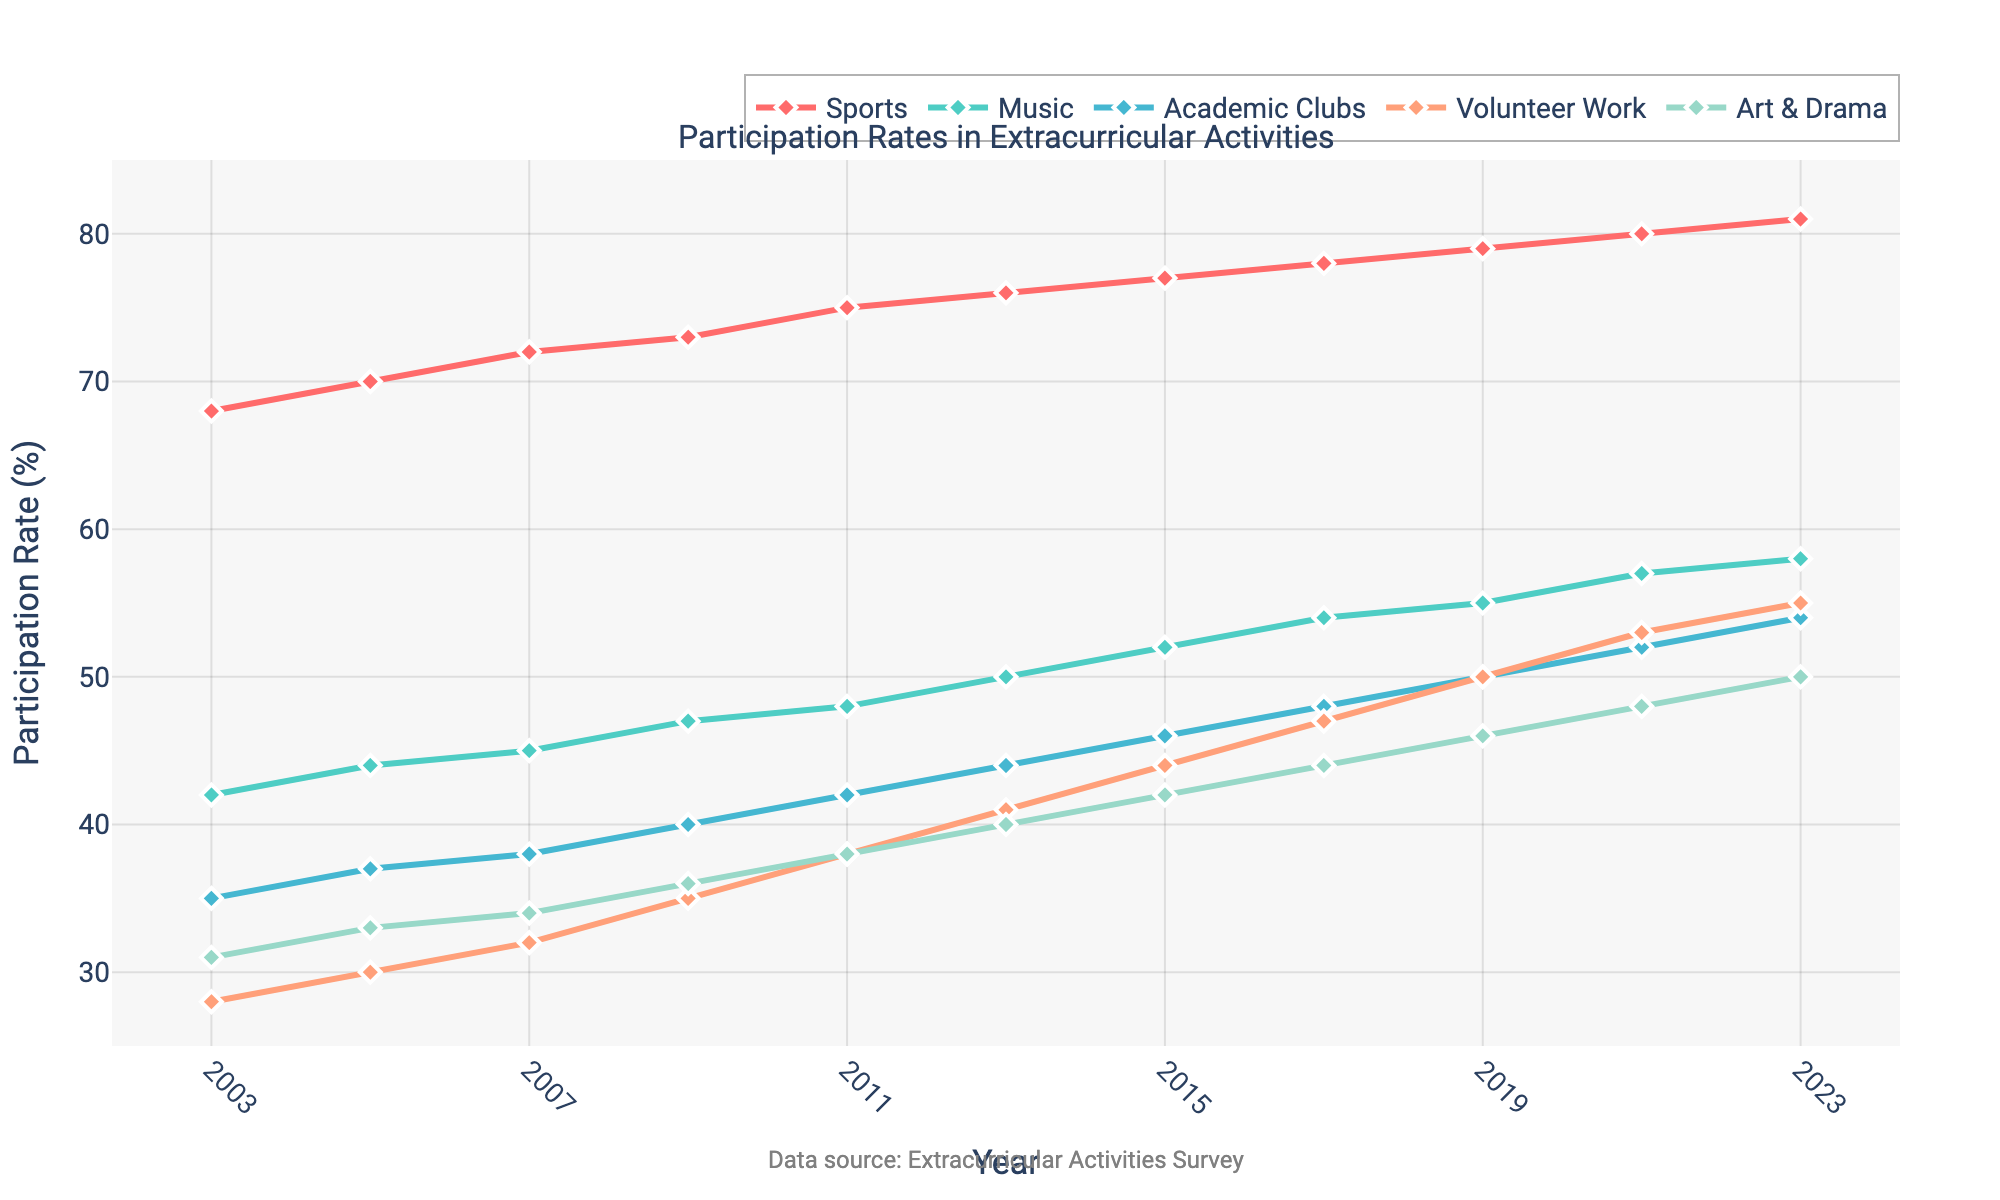What year had the highest participation in sports? To determine the year with the highest sports participation, we examine the line representing the sports on the chart and find the peak value. The highest sports participation rate is 81%, which occurs in the year 2023.
Answer: 2023 Which activity showed the greatest rate increase from 2003 to 2023? We need to calculate the increase in each activity's participation rate between 2003 and 2023 and then compare them. Sports increased by 13% (81% - 68%), Music by 16% (58% - 42%), Academic Clubs by 19% (54% - 35%), Volunteer Work by 27% (55% - 28%), and Art & Drama by 19% (50% - 31%). The highest increase is seen in Volunteer Work, which increased by 27%.
Answer: Volunteer Work How has participation in Music changed between 2011 and 2021? We compare the participation rates in Music for the years 2011 and 2021. In 2011, the participation rate was 48%, and in 2021, it was 57%. Therefore, there was an increase of 9% in Music participation from 2011 to 2021.
Answer: Increased by 9% In 2017, which activity had the lowest participation rate? By looking at the participation rates in 2017 for all activities, we identify the lowest rate. The rates are: Sports 78%, Music 54%, Academic Clubs 48%, Volunteer Work 47%, and Art & Drama 44%. The lowest rate is for Art & Drama at 44%.
Answer: Art & Drama What was the average participation rate for Academic Clubs from 2003 to 2023? To find the average, sum the participation rates of Academic Clubs for all given years and divide by the number of years. The rates are: 35, 37, 38, 40, 42, 44, 46, 48, 50, 52, 54. The total sum is 486, and there are 11 years, so the average is 486/11 ≈ 44.18%.
Answer: 44.18% Which year did Volunteer Work surpass 50% participation rate? We need to find the first year where the volunteer work participation rate exceeds 50%. Looking at the graph, this happens in 2019 when the participation rate reaches 50% and surpasses it in 2021 and 2023. The first occurrence is in 2019.
Answer: 2019 By how many percentage points did Art & Drama participation increase between 2003 and 2023? Subtract the participation rate of Art & Drama in 2003 from its rate in 2023. The rates are 31% in 2003 and 50% in 2023. The increase is 50% - 31% = 19 percentage points.
Answer: 19 percentage points Which activity had the steadiest increase over the years? We compare the trends of each activity line on the graph. The Sports line shows a consistent, steady upward trend, increasing by exactly 1% or 2% every two years.
Answer: Sports In which year did Academic Clubs first exceed a 45% participation rate? Look at the plotted line for Academic Clubs and find the first year where it exceeds 45%. It exceeds 45% for the first time in 2015 with a 46% participation rate.
Answer: 2015 